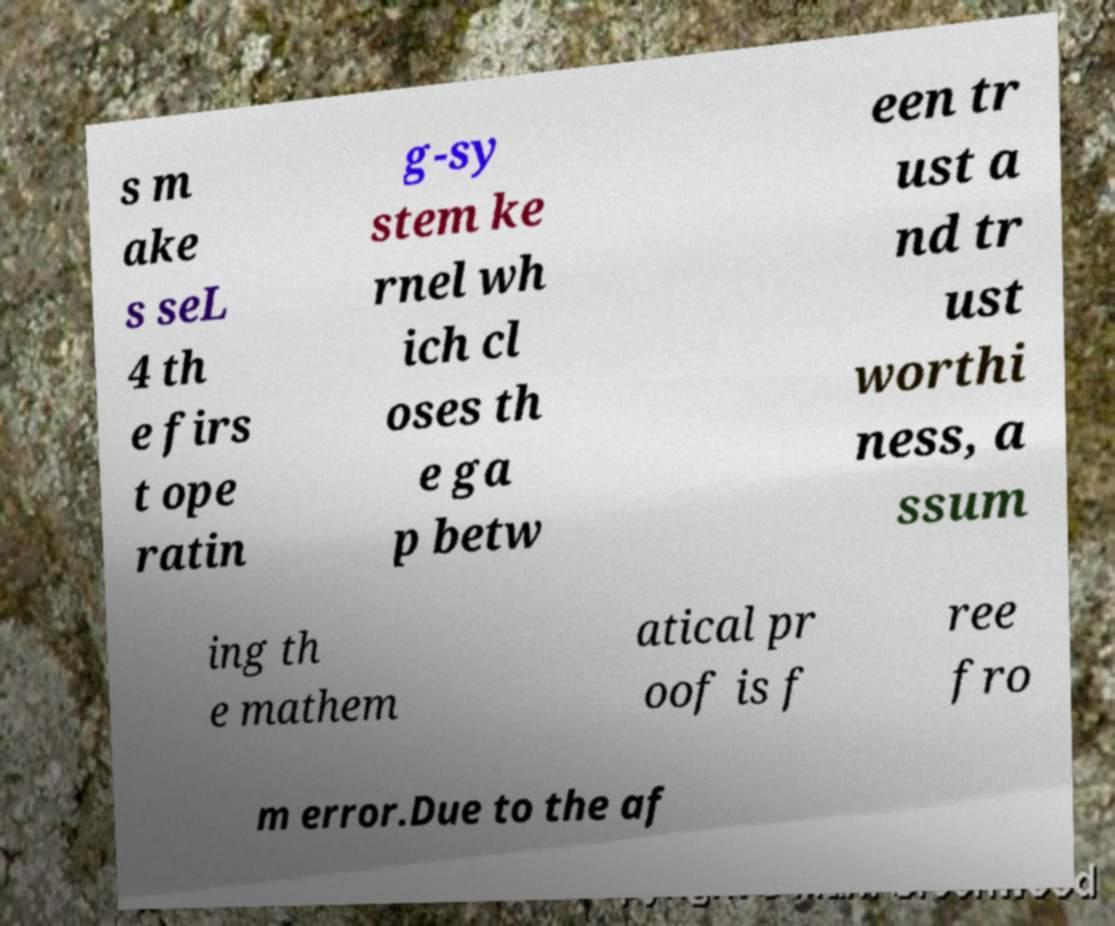There's text embedded in this image that I need extracted. Can you transcribe it verbatim? s m ake s seL 4 th e firs t ope ratin g-sy stem ke rnel wh ich cl oses th e ga p betw een tr ust a nd tr ust worthi ness, a ssum ing th e mathem atical pr oof is f ree fro m error.Due to the af 